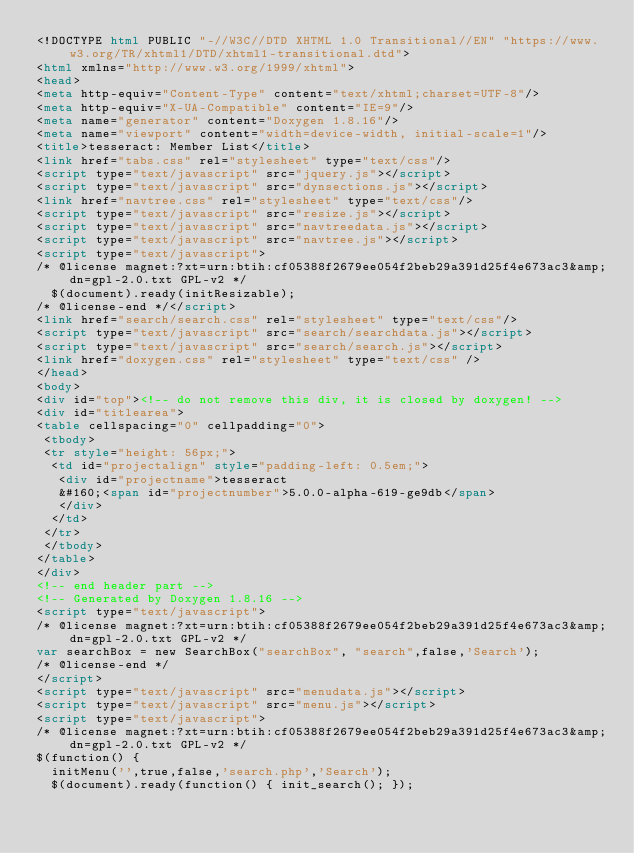<code> <loc_0><loc_0><loc_500><loc_500><_HTML_><!DOCTYPE html PUBLIC "-//W3C//DTD XHTML 1.0 Transitional//EN" "https://www.w3.org/TR/xhtml1/DTD/xhtml1-transitional.dtd">
<html xmlns="http://www.w3.org/1999/xhtml">
<head>
<meta http-equiv="Content-Type" content="text/xhtml;charset=UTF-8"/>
<meta http-equiv="X-UA-Compatible" content="IE=9"/>
<meta name="generator" content="Doxygen 1.8.16"/>
<meta name="viewport" content="width=device-width, initial-scale=1"/>
<title>tesseract: Member List</title>
<link href="tabs.css" rel="stylesheet" type="text/css"/>
<script type="text/javascript" src="jquery.js"></script>
<script type="text/javascript" src="dynsections.js"></script>
<link href="navtree.css" rel="stylesheet" type="text/css"/>
<script type="text/javascript" src="resize.js"></script>
<script type="text/javascript" src="navtreedata.js"></script>
<script type="text/javascript" src="navtree.js"></script>
<script type="text/javascript">
/* @license magnet:?xt=urn:btih:cf05388f2679ee054f2beb29a391d25f4e673ac3&amp;dn=gpl-2.0.txt GPL-v2 */
  $(document).ready(initResizable);
/* @license-end */</script>
<link href="search/search.css" rel="stylesheet" type="text/css"/>
<script type="text/javascript" src="search/searchdata.js"></script>
<script type="text/javascript" src="search/search.js"></script>
<link href="doxygen.css" rel="stylesheet" type="text/css" />
</head>
<body>
<div id="top"><!-- do not remove this div, it is closed by doxygen! -->
<div id="titlearea">
<table cellspacing="0" cellpadding="0">
 <tbody>
 <tr style="height: 56px;">
  <td id="projectalign" style="padding-left: 0.5em;">
   <div id="projectname">tesseract
   &#160;<span id="projectnumber">5.0.0-alpha-619-ge9db</span>
   </div>
  </td>
 </tr>
 </tbody>
</table>
</div>
<!-- end header part -->
<!-- Generated by Doxygen 1.8.16 -->
<script type="text/javascript">
/* @license magnet:?xt=urn:btih:cf05388f2679ee054f2beb29a391d25f4e673ac3&amp;dn=gpl-2.0.txt GPL-v2 */
var searchBox = new SearchBox("searchBox", "search",false,'Search');
/* @license-end */
</script>
<script type="text/javascript" src="menudata.js"></script>
<script type="text/javascript" src="menu.js"></script>
<script type="text/javascript">
/* @license magnet:?xt=urn:btih:cf05388f2679ee054f2beb29a391d25f4e673ac3&amp;dn=gpl-2.0.txt GPL-v2 */
$(function() {
  initMenu('',true,false,'search.php','Search');
  $(document).ready(function() { init_search(); });</code> 